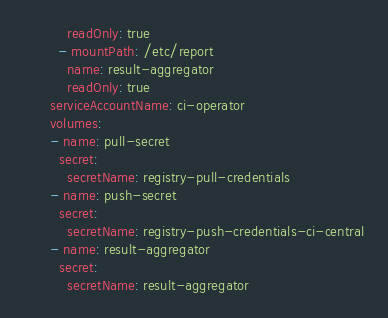<code> <loc_0><loc_0><loc_500><loc_500><_YAML_>          readOnly: true
        - mountPath: /etc/report
          name: result-aggregator
          readOnly: true
      serviceAccountName: ci-operator
      volumes:
      - name: pull-secret
        secret:
          secretName: registry-pull-credentials
      - name: push-secret
        secret:
          secretName: registry-push-credentials-ci-central
      - name: result-aggregator
        secret:
          secretName: result-aggregator
</code> 